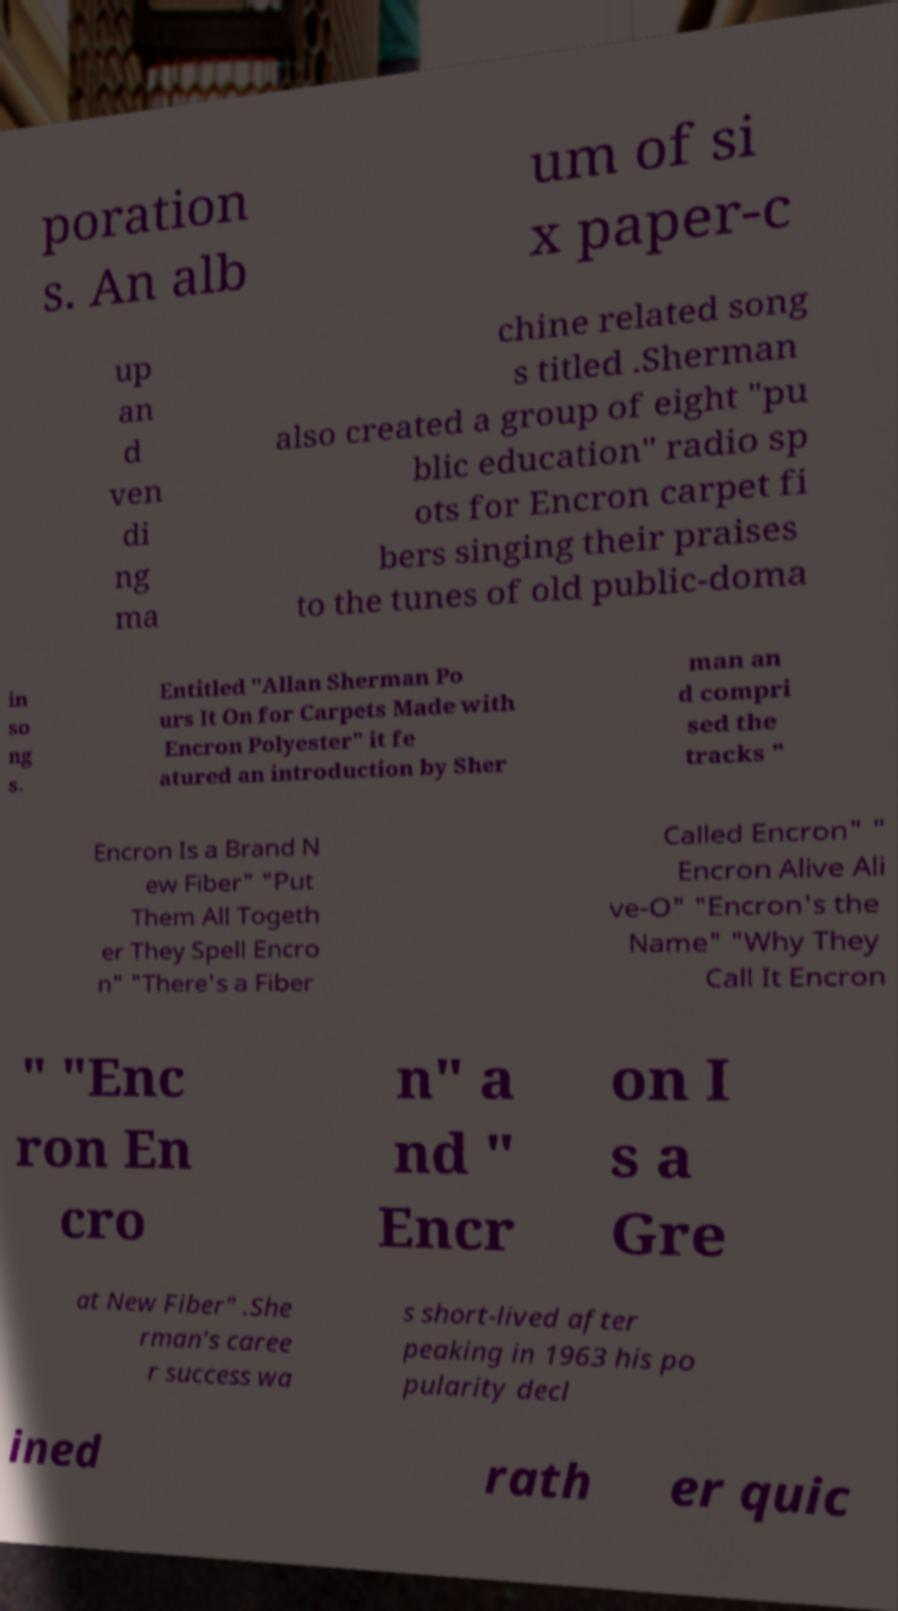There's text embedded in this image that I need extracted. Can you transcribe it verbatim? poration s. An alb um of si x paper-c up an d ven di ng ma chine related song s titled .Sherman also created a group of eight "pu blic education" radio sp ots for Encron carpet fi bers singing their praises to the tunes of old public-doma in so ng s. Entitled "Allan Sherman Po urs It On for Carpets Made with Encron Polyester" it fe atured an introduction by Sher man an d compri sed the tracks " Encron Is a Brand N ew Fiber" "Put Them All Togeth er They Spell Encro n" "There's a Fiber Called Encron" " Encron Alive Ali ve-O" "Encron's the Name" "Why They Call It Encron " "Enc ron En cro n" a nd " Encr on I s a Gre at New Fiber" .She rman's caree r success wa s short-lived after peaking in 1963 his po pularity decl ined rath er quic 